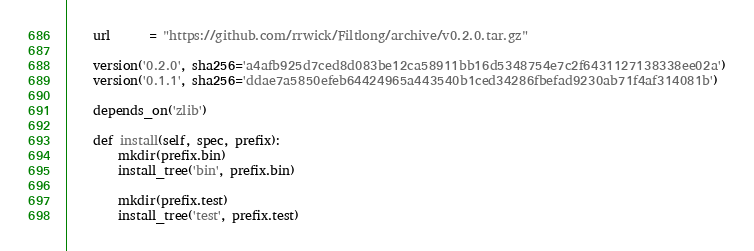Convert code to text. <code><loc_0><loc_0><loc_500><loc_500><_Python_>    url      = "https://github.com/rrwick/Filtlong/archive/v0.2.0.tar.gz"

    version('0.2.0', sha256='a4afb925d7ced8d083be12ca58911bb16d5348754e7c2f6431127138338ee02a')
    version('0.1.1', sha256='ddae7a5850efeb64424965a443540b1ced34286fbefad9230ab71f4af314081b')

    depends_on('zlib')

    def install(self, spec, prefix):
        mkdir(prefix.bin)
        install_tree('bin', prefix.bin)

        mkdir(prefix.test)
        install_tree('test', prefix.test)
</code> 